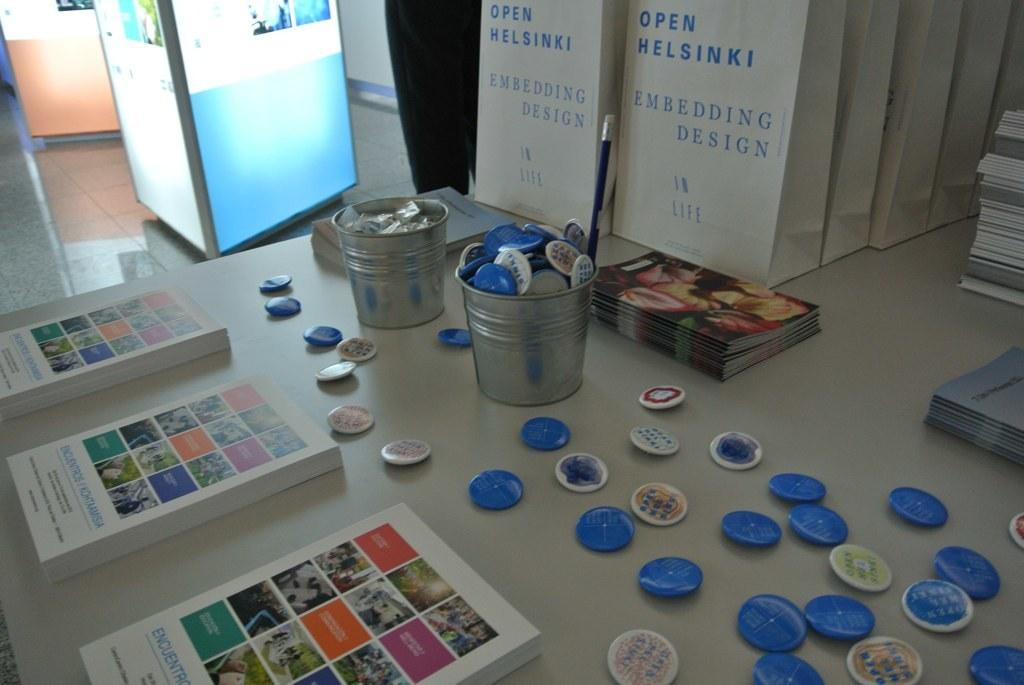<image>
Create a compact narrative representing the image presented. Books and badges are sitting on a table and a book called Embedding Design In Life is in the background. 